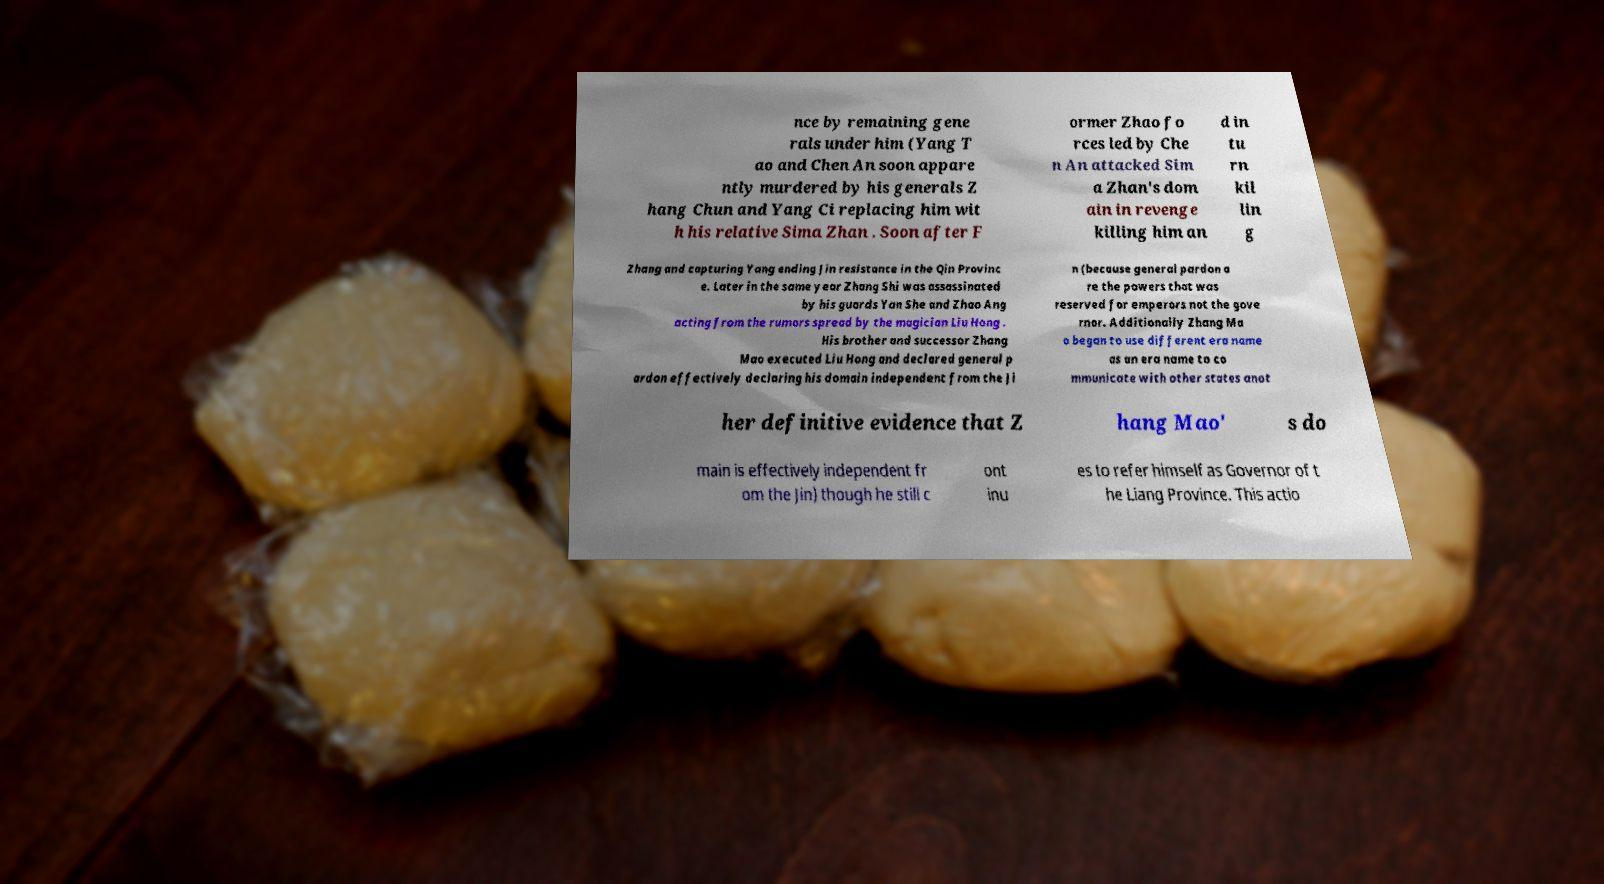Can you accurately transcribe the text from the provided image for me? nce by remaining gene rals under him (Yang T ao and Chen An soon appare ntly murdered by his generals Z hang Chun and Yang Ci replacing him wit h his relative Sima Zhan . Soon after F ormer Zhao fo rces led by Che n An attacked Sim a Zhan's dom ain in revenge killing him an d in tu rn kil lin g Zhang and capturing Yang ending Jin resistance in the Qin Provinc e. Later in the same year Zhang Shi was assassinated by his guards Yan She and Zhao Ang acting from the rumors spread by the magician Liu Hong . His brother and successor Zhang Mao executed Liu Hong and declared general p ardon effectively declaring his domain independent from the Ji n (because general pardon a re the powers that was reserved for emperors not the gove rnor. Additionally Zhang Ma o began to use different era name as an era name to co mmunicate with other states anot her definitive evidence that Z hang Mao' s do main is effectively independent fr om the Jin) though he still c ont inu es to refer himself as Governor of t he Liang Province. This actio 